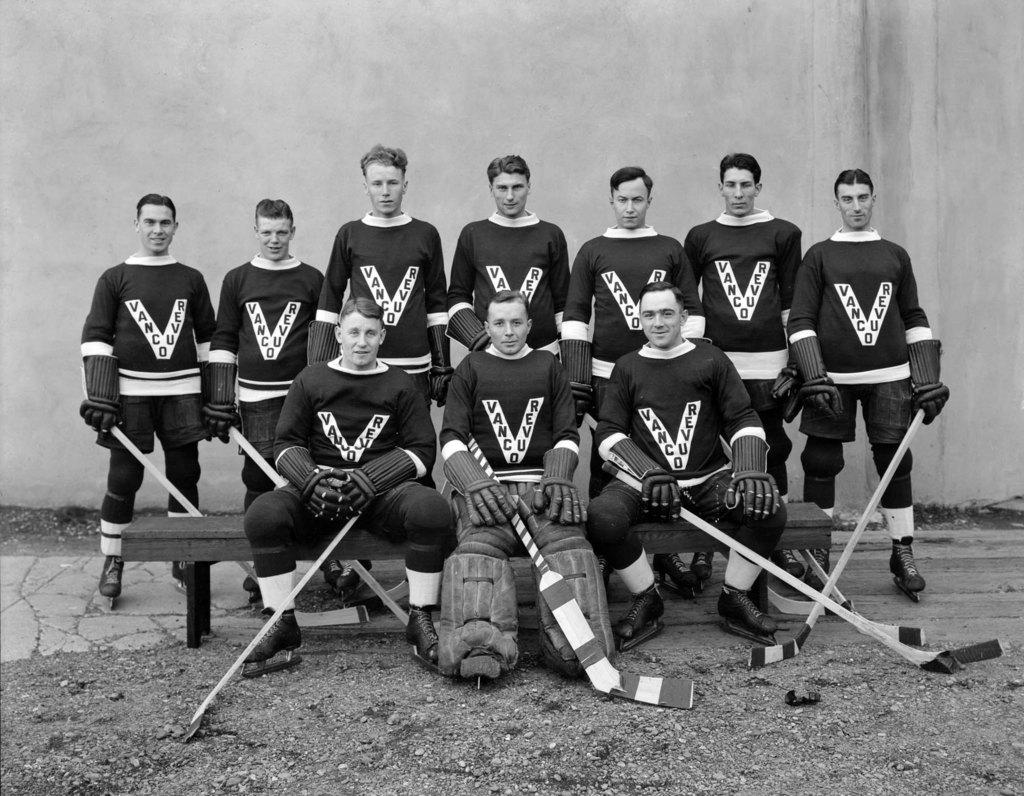What place is this team from?
Make the answer very short. Vancouver. What letter is printed on ever players shirt in white?
Give a very brief answer. V. 